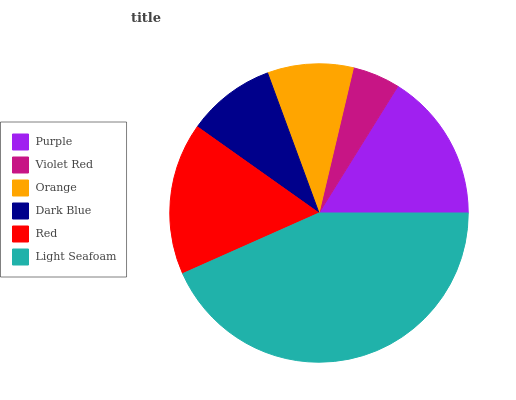Is Violet Red the minimum?
Answer yes or no. Yes. Is Light Seafoam the maximum?
Answer yes or no. Yes. Is Orange the minimum?
Answer yes or no. No. Is Orange the maximum?
Answer yes or no. No. Is Orange greater than Violet Red?
Answer yes or no. Yes. Is Violet Red less than Orange?
Answer yes or no. Yes. Is Violet Red greater than Orange?
Answer yes or no. No. Is Orange less than Violet Red?
Answer yes or no. No. Is Purple the high median?
Answer yes or no. Yes. Is Dark Blue the low median?
Answer yes or no. Yes. Is Violet Red the high median?
Answer yes or no. No. Is Violet Red the low median?
Answer yes or no. No. 